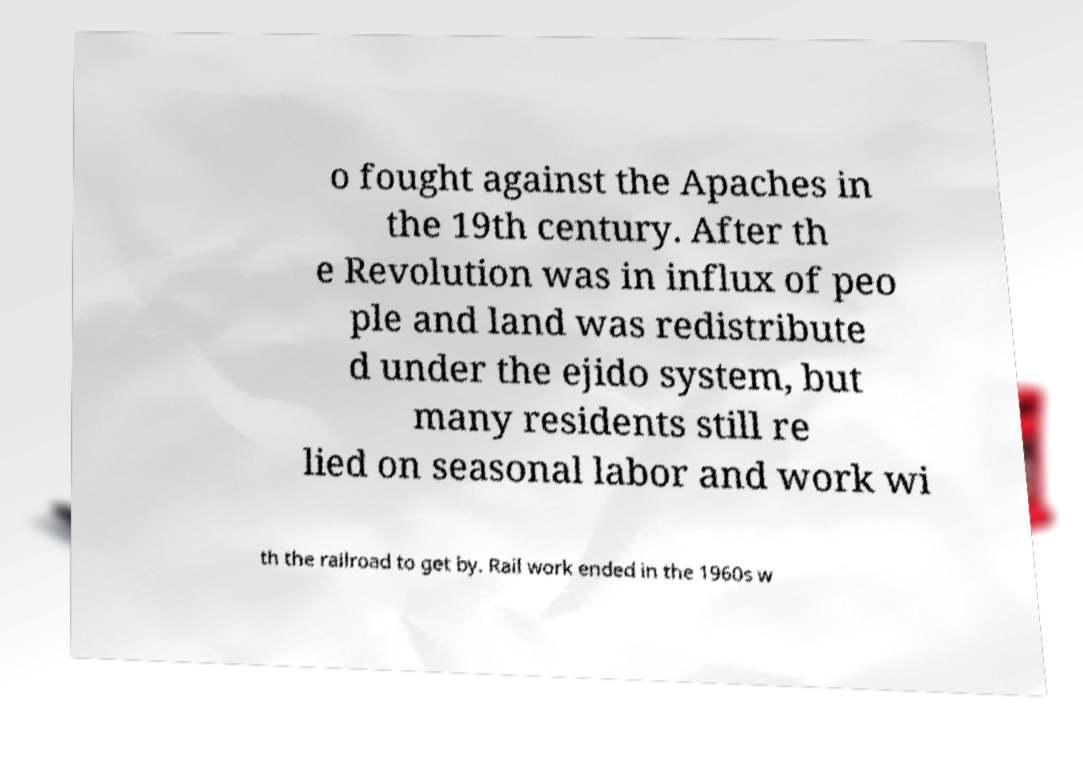I need the written content from this picture converted into text. Can you do that? o fought against the Apaches in the 19th century. After th e Revolution was in influx of peo ple and land was redistribute d under the ejido system, but many residents still re lied on seasonal labor and work wi th the railroad to get by. Rail work ended in the 1960s w 